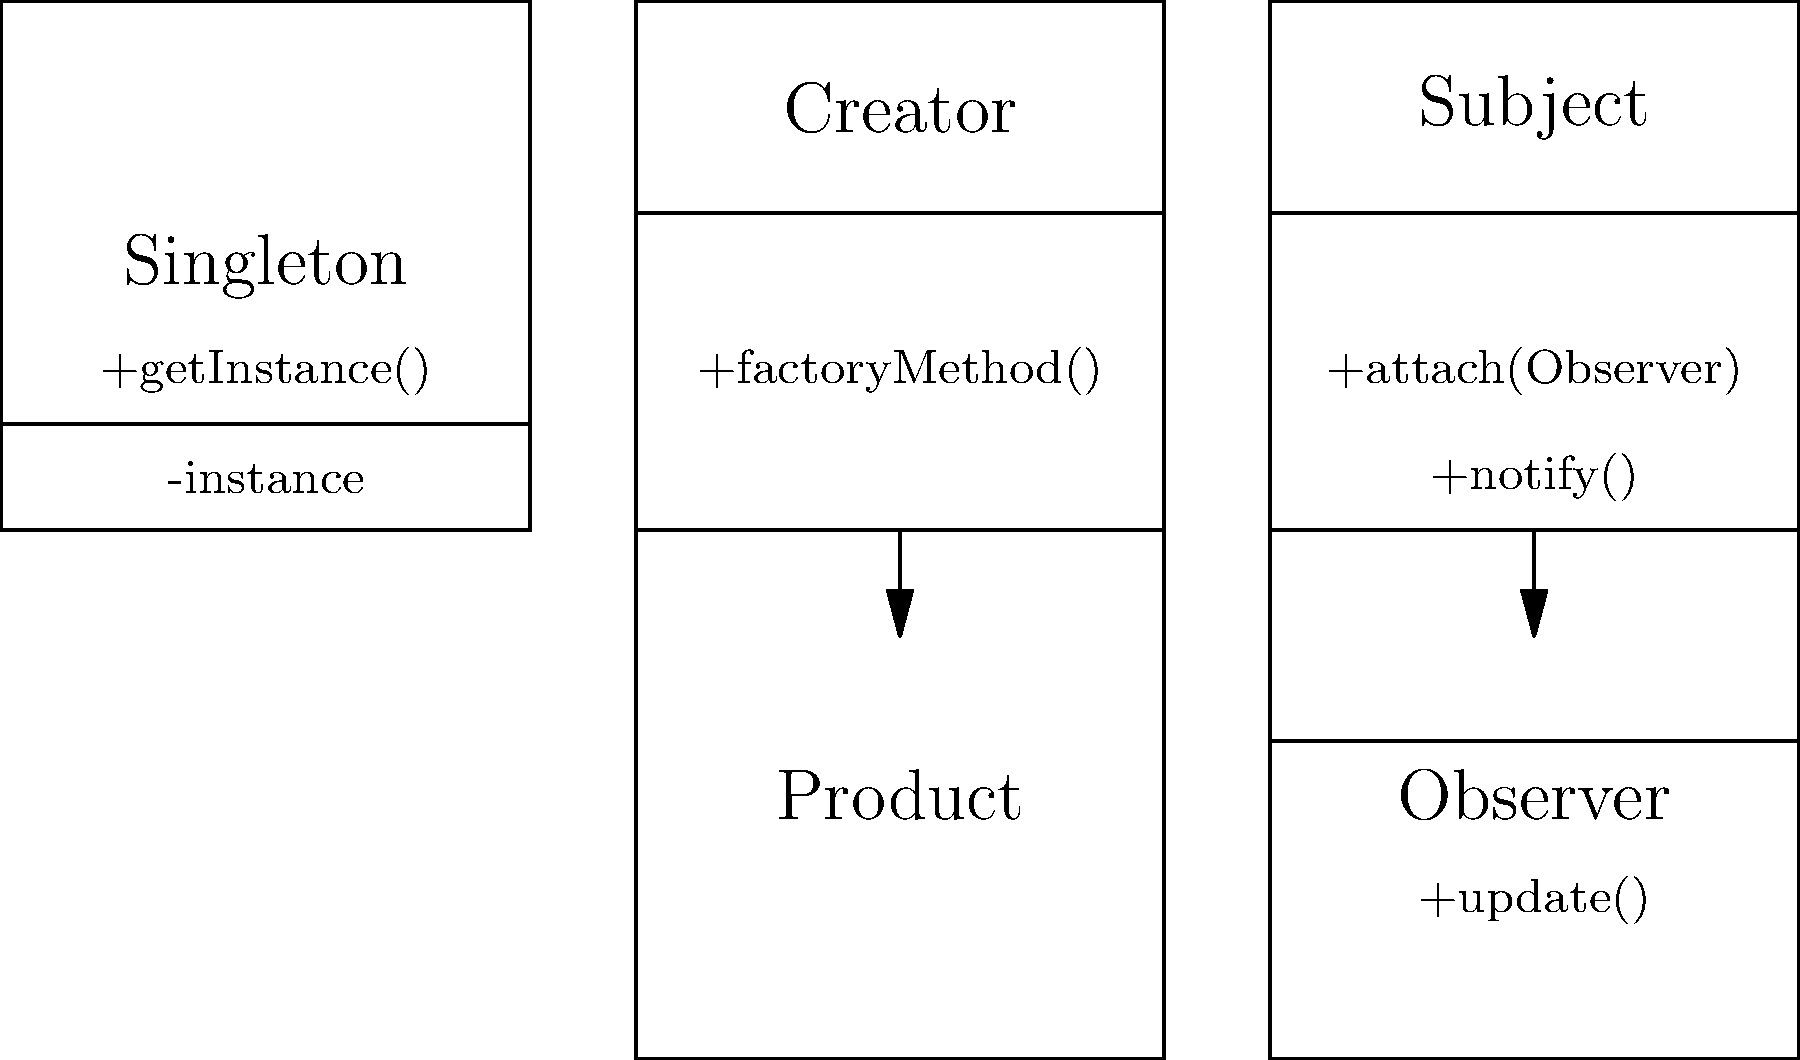Match the following software design patterns with their corresponding UML diagrams in the image:

1. Singleton Pattern
2. Factory Method Pattern
3. Observer Pattern

Which number corresponds to the UML diagram in the top-left corner of the image? To identify the correct design pattern for the UML diagram in the top-left corner, let's analyze each pattern:

1. Singleton Pattern:
   - Has a single class with a private constructor
   - Provides a static method to get the single instance
   - The diagram in the top-left shows a single class with "-instance" and "+getInstance()" methods, which are characteristic of the Singleton pattern

2. Factory Method Pattern:
   - Shows a Creator class with a factory method
   - Has a Product class that is created by the factory method
   - The diagram in the top-right shows this relationship between Creator and Product classes

3. Observer Pattern:
   - Has a Subject class with methods to attach observers and notify them
   - Has an Observer class with an update method
   - The diagram in the bottom-right shows this relationship between Subject and Observer classes

By examining the UML diagram in the top-left corner, we can see it matches the characteristics of the Singleton pattern. It has a single class with an instance variable and a getInstance() method, which are typical for implementing the Singleton pattern.

Therefore, the correct answer is the number corresponding to the Singleton Pattern.
Answer: 1 